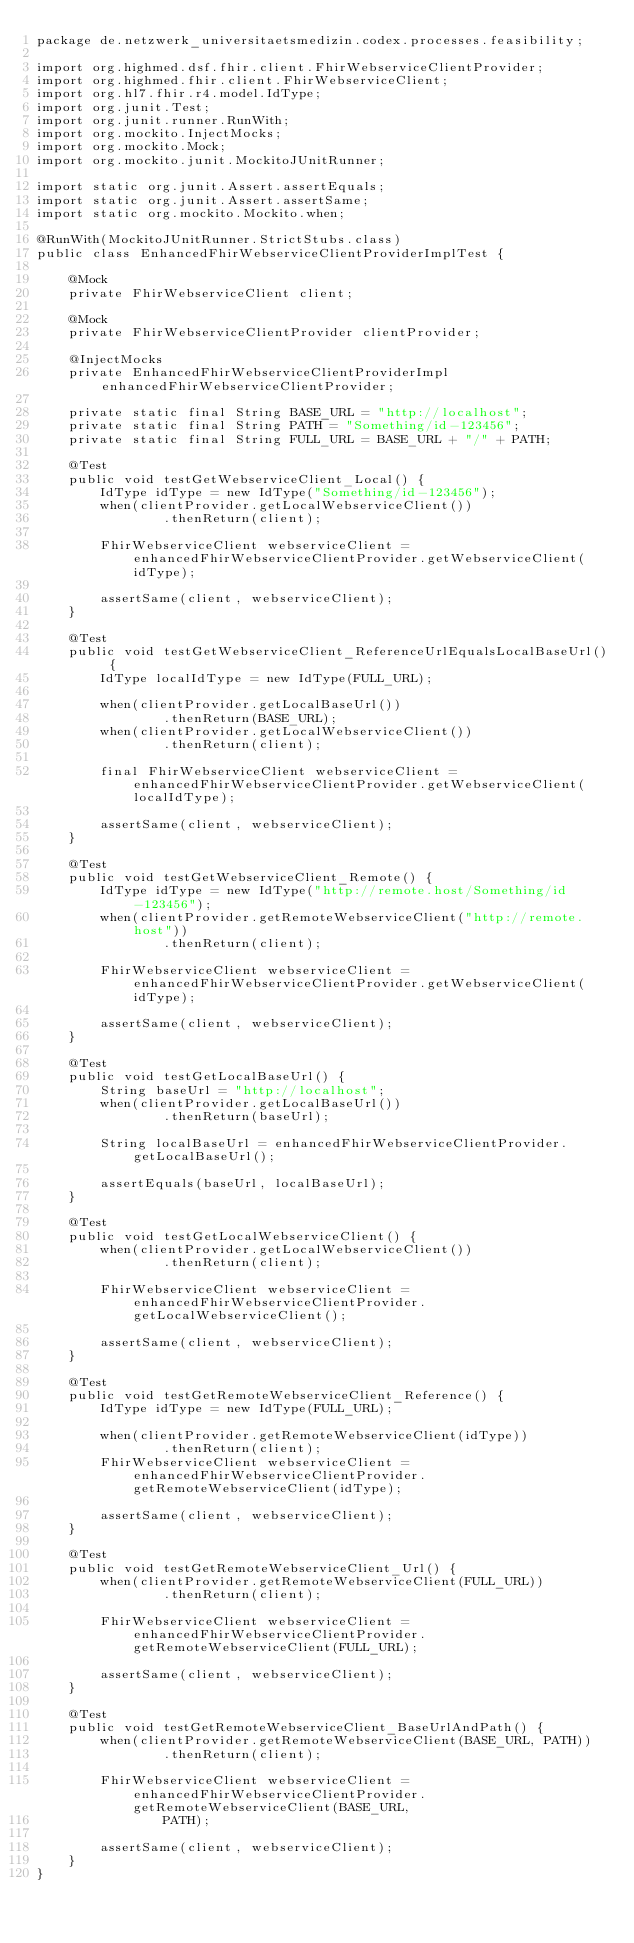Convert code to text. <code><loc_0><loc_0><loc_500><loc_500><_Java_>package de.netzwerk_universitaetsmedizin.codex.processes.feasibility;

import org.highmed.dsf.fhir.client.FhirWebserviceClientProvider;
import org.highmed.fhir.client.FhirWebserviceClient;
import org.hl7.fhir.r4.model.IdType;
import org.junit.Test;
import org.junit.runner.RunWith;
import org.mockito.InjectMocks;
import org.mockito.Mock;
import org.mockito.junit.MockitoJUnitRunner;

import static org.junit.Assert.assertEquals;
import static org.junit.Assert.assertSame;
import static org.mockito.Mockito.when;

@RunWith(MockitoJUnitRunner.StrictStubs.class)
public class EnhancedFhirWebserviceClientProviderImplTest {

    @Mock
    private FhirWebserviceClient client;

    @Mock
    private FhirWebserviceClientProvider clientProvider;

    @InjectMocks
    private EnhancedFhirWebserviceClientProviderImpl enhancedFhirWebserviceClientProvider;

    private static final String BASE_URL = "http://localhost";
    private static final String PATH = "Something/id-123456";
    private static final String FULL_URL = BASE_URL + "/" + PATH;

    @Test
    public void testGetWebserviceClient_Local() {
        IdType idType = new IdType("Something/id-123456");
        when(clientProvider.getLocalWebserviceClient())
                .thenReturn(client);

        FhirWebserviceClient webserviceClient = enhancedFhirWebserviceClientProvider.getWebserviceClient(idType);

        assertSame(client, webserviceClient);
    }

    @Test
    public void testGetWebserviceClient_ReferenceUrlEqualsLocalBaseUrl() {
        IdType localIdType = new IdType(FULL_URL);

        when(clientProvider.getLocalBaseUrl())
                .thenReturn(BASE_URL);
        when(clientProvider.getLocalWebserviceClient())
                .thenReturn(client);

        final FhirWebserviceClient webserviceClient = enhancedFhirWebserviceClientProvider.getWebserviceClient(localIdType);

        assertSame(client, webserviceClient);
    }

    @Test
    public void testGetWebserviceClient_Remote() {
        IdType idType = new IdType("http://remote.host/Something/id-123456");
        when(clientProvider.getRemoteWebserviceClient("http://remote.host"))
                .thenReturn(client);

        FhirWebserviceClient webserviceClient = enhancedFhirWebserviceClientProvider.getWebserviceClient(idType);

        assertSame(client, webserviceClient);
    }

    @Test
    public void testGetLocalBaseUrl() {
        String baseUrl = "http://localhost";
        when(clientProvider.getLocalBaseUrl())
                .thenReturn(baseUrl);

        String localBaseUrl = enhancedFhirWebserviceClientProvider.getLocalBaseUrl();

        assertEquals(baseUrl, localBaseUrl);
    }

    @Test
    public void testGetLocalWebserviceClient() {
        when(clientProvider.getLocalWebserviceClient())
                .thenReturn(client);

        FhirWebserviceClient webserviceClient = enhancedFhirWebserviceClientProvider.getLocalWebserviceClient();

        assertSame(client, webserviceClient);
    }

    @Test
    public void testGetRemoteWebserviceClient_Reference() {
        IdType idType = new IdType(FULL_URL);

        when(clientProvider.getRemoteWebserviceClient(idType))
                .thenReturn(client);
        FhirWebserviceClient webserviceClient = enhancedFhirWebserviceClientProvider.getRemoteWebserviceClient(idType);

        assertSame(client, webserviceClient);
    }

    @Test
    public void testGetRemoteWebserviceClient_Url() {
        when(clientProvider.getRemoteWebserviceClient(FULL_URL))
                .thenReturn(client);

        FhirWebserviceClient webserviceClient = enhancedFhirWebserviceClientProvider.getRemoteWebserviceClient(FULL_URL);

        assertSame(client, webserviceClient);
    }

    @Test
    public void testGetRemoteWebserviceClient_BaseUrlAndPath() {
        when(clientProvider.getRemoteWebserviceClient(BASE_URL, PATH))
                .thenReturn(client);

        FhirWebserviceClient webserviceClient = enhancedFhirWebserviceClientProvider.getRemoteWebserviceClient(BASE_URL,
                PATH);

        assertSame(client, webserviceClient);
    }
}
</code> 